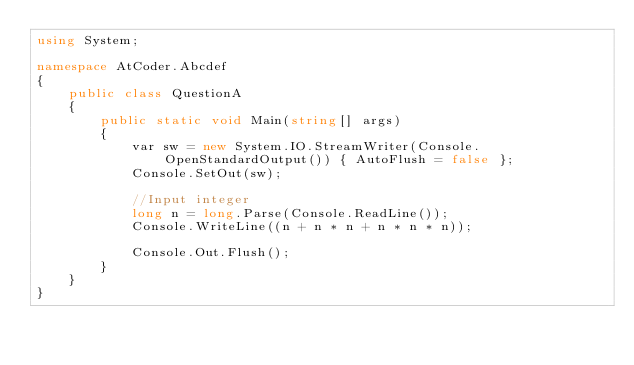Convert code to text. <code><loc_0><loc_0><loc_500><loc_500><_C#_>using System;

namespace AtCoder.Abcdef
{
    public class QuestionA
    {
        public static void Main(string[] args)
        {
            var sw = new System.IO.StreamWriter(Console.OpenStandardOutput()) { AutoFlush = false };
            Console.SetOut(sw);

            //Input integer
            long n = long.Parse(Console.ReadLine());
            Console.WriteLine((n + n * n + n * n * n));

            Console.Out.Flush();
        }
    }
}
</code> 